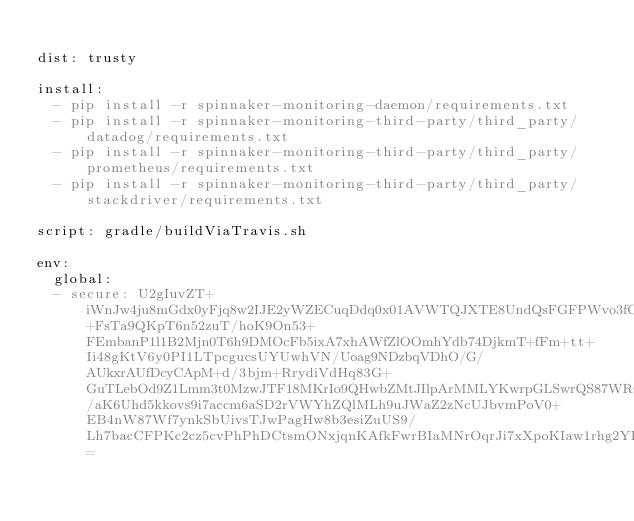<code> <loc_0><loc_0><loc_500><loc_500><_YAML_>
dist: trusty

install:
  - pip install -r spinnaker-monitoring-daemon/requirements.txt
  - pip install -r spinnaker-monitoring-third-party/third_party/datadog/requirements.txt
  - pip install -r spinnaker-monitoring-third-party/third_party/prometheus/requirements.txt
  - pip install -r spinnaker-monitoring-third-party/third_party/stackdriver/requirements.txt

script: gradle/buildViaTravis.sh

env:
  global:
  - secure: U2gIuvZT+iWnJw4ju8mGdx0yFjq8w2IJE2yWZECuqDdq0x01AVWTQJXTE8UndQsFGFPWvo3fOTgyJ6J6tvwhO29Cp6gPyw0+FsTa9QKpT6n52zuT/hoK9On53+FEmbanP1l1B2Mjn0T6h9DMOcFb5ixA7xhAWfZlOOmhYdb74DjkmT+fFm+tt+Ii48gKtV6y0PI1LTpcgucsUYUwhVN/Uoag9NDzbqVDhO/G/AUkxrAUfDcyCApM+d/3bjm+RrydiVdHq83G+GuTLebOd9Z1Lmm3t0MzwJTF18MKrIo9QHwbZMtJIlpArMMLYKwrpGLSwrQS87WRQohCopWFyfeVaGFeJ4989ig/aK6Uhd5kkovs9i7accm6aSD2rVWYhZQlMLh9uJWaZ2zNcUJbvmPoV0+EB4nW87Wf7ynkSbUivsTJwPagHw8b3esiZuUS9/Lh7bacCFPKc2cz5cvPhPhDCtsmONxjqnKAfkFwrBIaMNrOqrJi7xXpoKIaw1rhg2YIBNsxGgc3yZ17G2BN8QIEtMrwMGKINgReOCKMpuqRR9UhR1MfFqT6ahhtoMe3tirJYakIeeBkzrJVQNJm5BzsIVYDJySm6F7cT4PQo7DfJKAZppyMuTfQkDHsSozl0iZ6Lhc0Ii7j27Nkg7seDf3OawsXdHhEOJlrOLkKsHGe5vA=</code> 